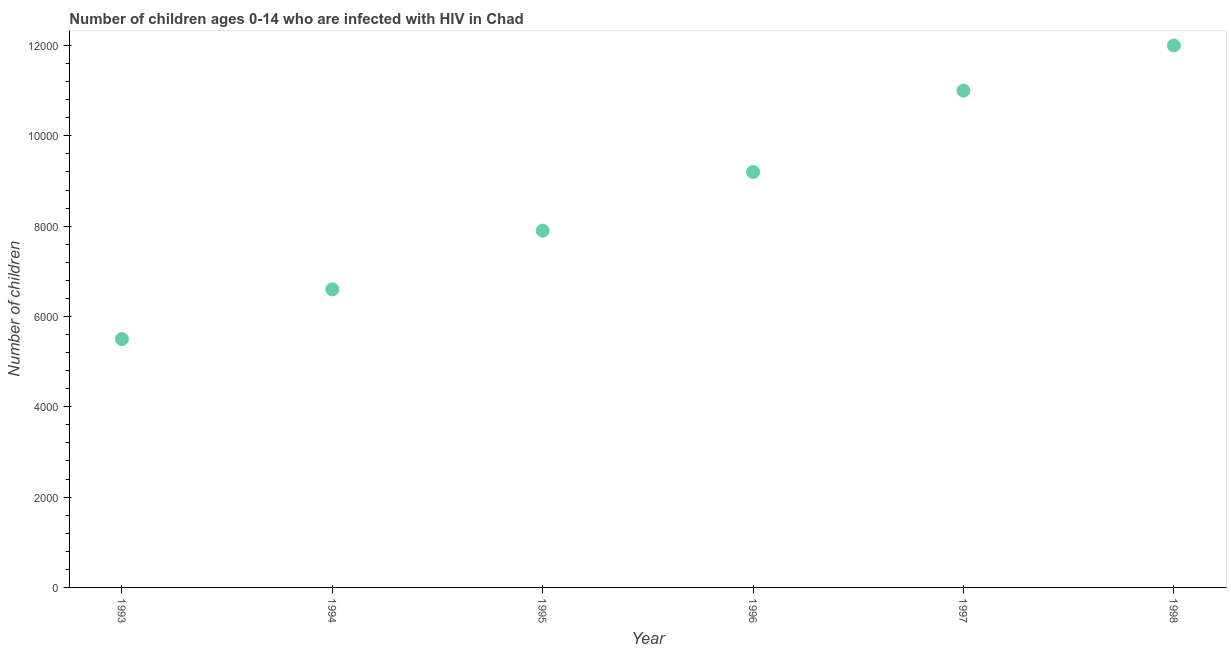What is the number of children living with hiv in 1994?
Keep it short and to the point. 6600. Across all years, what is the maximum number of children living with hiv?
Your answer should be very brief. 1.20e+04. Across all years, what is the minimum number of children living with hiv?
Give a very brief answer. 5500. In which year was the number of children living with hiv minimum?
Give a very brief answer. 1993. What is the sum of the number of children living with hiv?
Your answer should be very brief. 5.22e+04. What is the difference between the number of children living with hiv in 1995 and 1998?
Your response must be concise. -4100. What is the average number of children living with hiv per year?
Your answer should be very brief. 8700. What is the median number of children living with hiv?
Give a very brief answer. 8550. What is the ratio of the number of children living with hiv in 1993 to that in 1994?
Provide a succinct answer. 0.83. Is the number of children living with hiv in 1993 less than that in 1997?
Your response must be concise. Yes. Is the difference between the number of children living with hiv in 1995 and 1996 greater than the difference between any two years?
Your answer should be very brief. No. What is the difference between the highest and the second highest number of children living with hiv?
Keep it short and to the point. 1000. Is the sum of the number of children living with hiv in 1997 and 1998 greater than the maximum number of children living with hiv across all years?
Give a very brief answer. Yes. What is the difference between the highest and the lowest number of children living with hiv?
Ensure brevity in your answer.  6500. Does the number of children living with hiv monotonically increase over the years?
Your response must be concise. Yes. How many dotlines are there?
Offer a terse response. 1. What is the difference between two consecutive major ticks on the Y-axis?
Your answer should be very brief. 2000. Does the graph contain any zero values?
Give a very brief answer. No. Does the graph contain grids?
Your answer should be very brief. No. What is the title of the graph?
Make the answer very short. Number of children ages 0-14 who are infected with HIV in Chad. What is the label or title of the X-axis?
Offer a terse response. Year. What is the label or title of the Y-axis?
Your response must be concise. Number of children. What is the Number of children in 1993?
Offer a terse response. 5500. What is the Number of children in 1994?
Offer a very short reply. 6600. What is the Number of children in 1995?
Offer a very short reply. 7900. What is the Number of children in 1996?
Your answer should be compact. 9200. What is the Number of children in 1997?
Your answer should be compact. 1.10e+04. What is the Number of children in 1998?
Provide a short and direct response. 1.20e+04. What is the difference between the Number of children in 1993 and 1994?
Provide a short and direct response. -1100. What is the difference between the Number of children in 1993 and 1995?
Offer a terse response. -2400. What is the difference between the Number of children in 1993 and 1996?
Make the answer very short. -3700. What is the difference between the Number of children in 1993 and 1997?
Provide a succinct answer. -5500. What is the difference between the Number of children in 1993 and 1998?
Your answer should be very brief. -6500. What is the difference between the Number of children in 1994 and 1995?
Offer a very short reply. -1300. What is the difference between the Number of children in 1994 and 1996?
Offer a very short reply. -2600. What is the difference between the Number of children in 1994 and 1997?
Make the answer very short. -4400. What is the difference between the Number of children in 1994 and 1998?
Provide a succinct answer. -5400. What is the difference between the Number of children in 1995 and 1996?
Your response must be concise. -1300. What is the difference between the Number of children in 1995 and 1997?
Offer a very short reply. -3100. What is the difference between the Number of children in 1995 and 1998?
Provide a succinct answer. -4100. What is the difference between the Number of children in 1996 and 1997?
Provide a succinct answer. -1800. What is the difference between the Number of children in 1996 and 1998?
Your response must be concise. -2800. What is the difference between the Number of children in 1997 and 1998?
Your response must be concise. -1000. What is the ratio of the Number of children in 1993 to that in 1994?
Offer a terse response. 0.83. What is the ratio of the Number of children in 1993 to that in 1995?
Provide a succinct answer. 0.7. What is the ratio of the Number of children in 1993 to that in 1996?
Your answer should be very brief. 0.6. What is the ratio of the Number of children in 1993 to that in 1998?
Ensure brevity in your answer.  0.46. What is the ratio of the Number of children in 1994 to that in 1995?
Make the answer very short. 0.83. What is the ratio of the Number of children in 1994 to that in 1996?
Offer a very short reply. 0.72. What is the ratio of the Number of children in 1994 to that in 1997?
Your answer should be very brief. 0.6. What is the ratio of the Number of children in 1994 to that in 1998?
Keep it short and to the point. 0.55. What is the ratio of the Number of children in 1995 to that in 1996?
Your response must be concise. 0.86. What is the ratio of the Number of children in 1995 to that in 1997?
Provide a short and direct response. 0.72. What is the ratio of the Number of children in 1995 to that in 1998?
Provide a succinct answer. 0.66. What is the ratio of the Number of children in 1996 to that in 1997?
Your answer should be very brief. 0.84. What is the ratio of the Number of children in 1996 to that in 1998?
Provide a short and direct response. 0.77. What is the ratio of the Number of children in 1997 to that in 1998?
Provide a short and direct response. 0.92. 